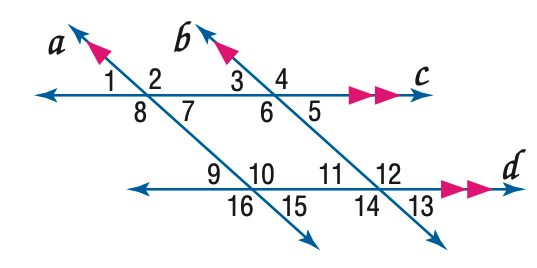Answer the mathemtical geometry problem and directly provide the correct option letter.
Question: In the figure, m \angle 3 = 43. Find the measure of \angle 7.
Choices: A: 43 B: 53 C: 127 D: 137 A 